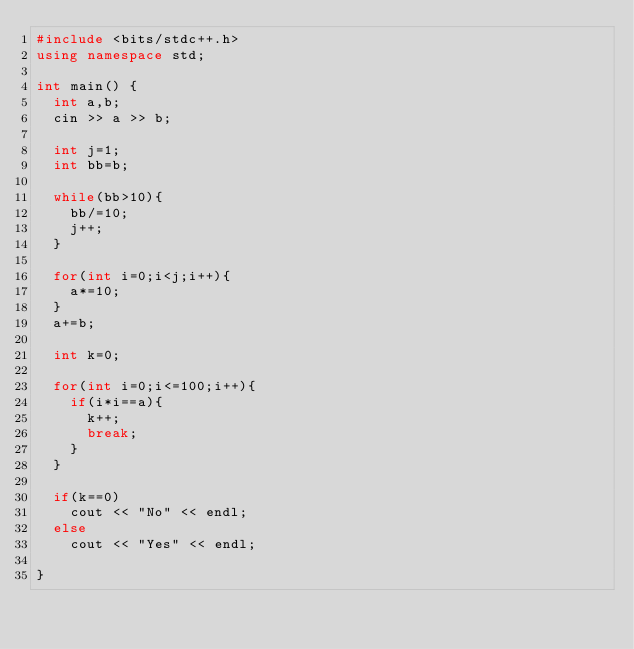Convert code to text. <code><loc_0><loc_0><loc_500><loc_500><_C++_>#include <bits/stdc++.h>
using namespace std;
 
int main() {
  int a,b;
  cin >> a >> b;
  
  int j=1;
  int bb=b;
  
  while(bb>10){
    bb/=10;
    j++;
  }
  
  for(int i=0;i<j;i++){
    a*=10;
  }
  a+=b;
  
  int k=0;
  
  for(int i=0;i<=100;i++){
    if(i*i==a){
      k++;
      break;
    }
  }
  
  if(k==0)
    cout << "No" << endl;
  else
    cout << "Yes" << endl;
  
}</code> 